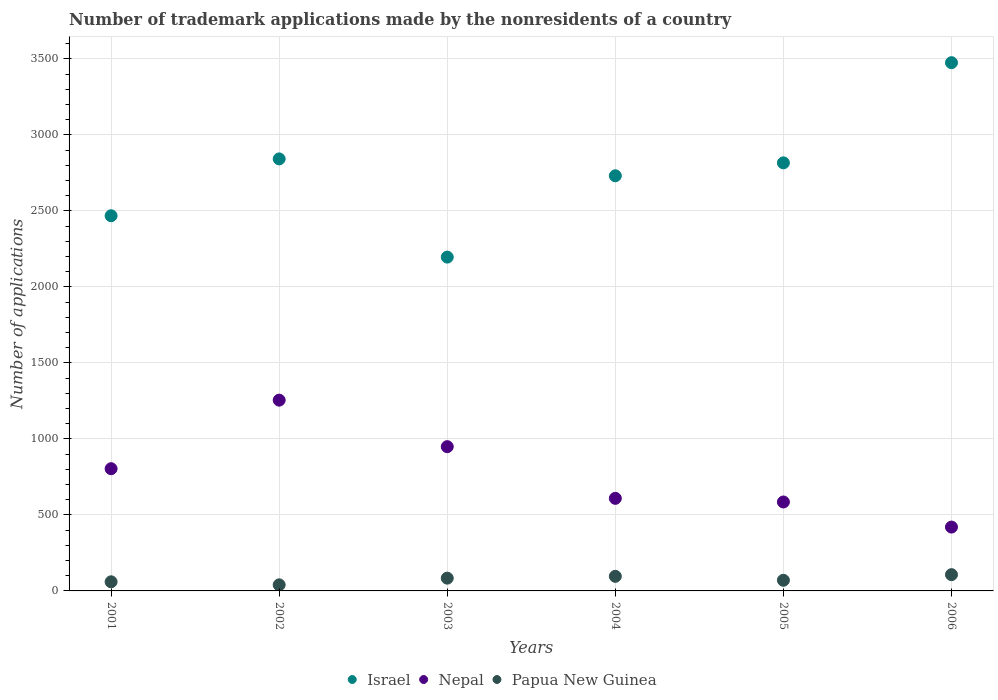How many different coloured dotlines are there?
Provide a succinct answer. 3. What is the number of trademark applications made by the nonresidents in Israel in 2006?
Your answer should be very brief. 3475. Across all years, what is the maximum number of trademark applications made by the nonresidents in Nepal?
Make the answer very short. 1255. Across all years, what is the minimum number of trademark applications made by the nonresidents in Nepal?
Your response must be concise. 420. In which year was the number of trademark applications made by the nonresidents in Israel maximum?
Provide a short and direct response. 2006. What is the total number of trademark applications made by the nonresidents in Papua New Guinea in the graph?
Keep it short and to the point. 457. What is the difference between the number of trademark applications made by the nonresidents in Nepal in 2001 and that in 2005?
Provide a short and direct response. 219. What is the difference between the number of trademark applications made by the nonresidents in Israel in 2001 and the number of trademark applications made by the nonresidents in Nepal in 2005?
Your answer should be very brief. 1883. What is the average number of trademark applications made by the nonresidents in Israel per year?
Keep it short and to the point. 2754.67. In the year 2002, what is the difference between the number of trademark applications made by the nonresidents in Papua New Guinea and number of trademark applications made by the nonresidents in Israel?
Your response must be concise. -2802. What is the ratio of the number of trademark applications made by the nonresidents in Israel in 2002 to that in 2006?
Provide a succinct answer. 0.82. Is the number of trademark applications made by the nonresidents in Papua New Guinea in 2005 less than that in 2006?
Give a very brief answer. Yes. Is the difference between the number of trademark applications made by the nonresidents in Papua New Guinea in 2003 and 2004 greater than the difference between the number of trademark applications made by the nonresidents in Israel in 2003 and 2004?
Your response must be concise. Yes. What is the difference between the highest and the second highest number of trademark applications made by the nonresidents in Nepal?
Ensure brevity in your answer.  306. In how many years, is the number of trademark applications made by the nonresidents in Papua New Guinea greater than the average number of trademark applications made by the nonresidents in Papua New Guinea taken over all years?
Your response must be concise. 3. Is the number of trademark applications made by the nonresidents in Papua New Guinea strictly less than the number of trademark applications made by the nonresidents in Israel over the years?
Give a very brief answer. Yes. How many years are there in the graph?
Your answer should be compact. 6. What is the difference between two consecutive major ticks on the Y-axis?
Your answer should be very brief. 500. Are the values on the major ticks of Y-axis written in scientific E-notation?
Your answer should be very brief. No. Does the graph contain any zero values?
Provide a short and direct response. No. Does the graph contain grids?
Offer a very short reply. Yes. Where does the legend appear in the graph?
Keep it short and to the point. Bottom center. How are the legend labels stacked?
Offer a terse response. Horizontal. What is the title of the graph?
Your answer should be very brief. Number of trademark applications made by the nonresidents of a country. Does "Eritrea" appear as one of the legend labels in the graph?
Provide a short and direct response. No. What is the label or title of the Y-axis?
Keep it short and to the point. Number of applications. What is the Number of applications in Israel in 2001?
Ensure brevity in your answer.  2468. What is the Number of applications of Nepal in 2001?
Your response must be concise. 804. What is the Number of applications of Israel in 2002?
Make the answer very short. 2842. What is the Number of applications in Nepal in 2002?
Offer a terse response. 1255. What is the Number of applications in Papua New Guinea in 2002?
Provide a short and direct response. 40. What is the Number of applications of Israel in 2003?
Your response must be concise. 2196. What is the Number of applications of Nepal in 2003?
Make the answer very short. 949. What is the Number of applications in Israel in 2004?
Your response must be concise. 2731. What is the Number of applications of Nepal in 2004?
Your answer should be compact. 609. What is the Number of applications in Papua New Guinea in 2004?
Make the answer very short. 96. What is the Number of applications of Israel in 2005?
Provide a short and direct response. 2816. What is the Number of applications in Nepal in 2005?
Offer a terse response. 585. What is the Number of applications of Israel in 2006?
Make the answer very short. 3475. What is the Number of applications in Nepal in 2006?
Provide a succinct answer. 420. What is the Number of applications in Papua New Guinea in 2006?
Offer a very short reply. 107. Across all years, what is the maximum Number of applications of Israel?
Ensure brevity in your answer.  3475. Across all years, what is the maximum Number of applications in Nepal?
Your response must be concise. 1255. Across all years, what is the maximum Number of applications of Papua New Guinea?
Offer a very short reply. 107. Across all years, what is the minimum Number of applications of Israel?
Your response must be concise. 2196. Across all years, what is the minimum Number of applications of Nepal?
Provide a succinct answer. 420. Across all years, what is the minimum Number of applications of Papua New Guinea?
Make the answer very short. 40. What is the total Number of applications in Israel in the graph?
Offer a very short reply. 1.65e+04. What is the total Number of applications in Nepal in the graph?
Keep it short and to the point. 4622. What is the total Number of applications in Papua New Guinea in the graph?
Provide a short and direct response. 457. What is the difference between the Number of applications in Israel in 2001 and that in 2002?
Offer a very short reply. -374. What is the difference between the Number of applications in Nepal in 2001 and that in 2002?
Make the answer very short. -451. What is the difference between the Number of applications in Israel in 2001 and that in 2003?
Your answer should be compact. 272. What is the difference between the Number of applications in Nepal in 2001 and that in 2003?
Offer a very short reply. -145. What is the difference between the Number of applications in Papua New Guinea in 2001 and that in 2003?
Make the answer very short. -24. What is the difference between the Number of applications of Israel in 2001 and that in 2004?
Keep it short and to the point. -263. What is the difference between the Number of applications of Nepal in 2001 and that in 2004?
Your answer should be compact. 195. What is the difference between the Number of applications in Papua New Guinea in 2001 and that in 2004?
Make the answer very short. -36. What is the difference between the Number of applications in Israel in 2001 and that in 2005?
Provide a short and direct response. -348. What is the difference between the Number of applications of Nepal in 2001 and that in 2005?
Offer a terse response. 219. What is the difference between the Number of applications of Israel in 2001 and that in 2006?
Offer a terse response. -1007. What is the difference between the Number of applications in Nepal in 2001 and that in 2006?
Give a very brief answer. 384. What is the difference between the Number of applications of Papua New Guinea in 2001 and that in 2006?
Make the answer very short. -47. What is the difference between the Number of applications in Israel in 2002 and that in 2003?
Ensure brevity in your answer.  646. What is the difference between the Number of applications of Nepal in 2002 and that in 2003?
Your answer should be very brief. 306. What is the difference between the Number of applications of Papua New Guinea in 2002 and that in 2003?
Provide a short and direct response. -44. What is the difference between the Number of applications of Israel in 2002 and that in 2004?
Your answer should be very brief. 111. What is the difference between the Number of applications of Nepal in 2002 and that in 2004?
Your answer should be compact. 646. What is the difference between the Number of applications in Papua New Guinea in 2002 and that in 2004?
Ensure brevity in your answer.  -56. What is the difference between the Number of applications in Israel in 2002 and that in 2005?
Your answer should be very brief. 26. What is the difference between the Number of applications in Nepal in 2002 and that in 2005?
Offer a very short reply. 670. What is the difference between the Number of applications of Israel in 2002 and that in 2006?
Your answer should be compact. -633. What is the difference between the Number of applications of Nepal in 2002 and that in 2006?
Keep it short and to the point. 835. What is the difference between the Number of applications of Papua New Guinea in 2002 and that in 2006?
Offer a very short reply. -67. What is the difference between the Number of applications of Israel in 2003 and that in 2004?
Give a very brief answer. -535. What is the difference between the Number of applications of Nepal in 2003 and that in 2004?
Keep it short and to the point. 340. What is the difference between the Number of applications in Israel in 2003 and that in 2005?
Your answer should be very brief. -620. What is the difference between the Number of applications in Nepal in 2003 and that in 2005?
Give a very brief answer. 364. What is the difference between the Number of applications of Israel in 2003 and that in 2006?
Provide a succinct answer. -1279. What is the difference between the Number of applications in Nepal in 2003 and that in 2006?
Offer a very short reply. 529. What is the difference between the Number of applications of Israel in 2004 and that in 2005?
Give a very brief answer. -85. What is the difference between the Number of applications of Papua New Guinea in 2004 and that in 2005?
Ensure brevity in your answer.  26. What is the difference between the Number of applications of Israel in 2004 and that in 2006?
Your response must be concise. -744. What is the difference between the Number of applications in Nepal in 2004 and that in 2006?
Offer a terse response. 189. What is the difference between the Number of applications in Israel in 2005 and that in 2006?
Provide a short and direct response. -659. What is the difference between the Number of applications of Nepal in 2005 and that in 2006?
Your response must be concise. 165. What is the difference between the Number of applications of Papua New Guinea in 2005 and that in 2006?
Make the answer very short. -37. What is the difference between the Number of applications in Israel in 2001 and the Number of applications in Nepal in 2002?
Your answer should be very brief. 1213. What is the difference between the Number of applications of Israel in 2001 and the Number of applications of Papua New Guinea in 2002?
Keep it short and to the point. 2428. What is the difference between the Number of applications of Nepal in 2001 and the Number of applications of Papua New Guinea in 2002?
Provide a succinct answer. 764. What is the difference between the Number of applications in Israel in 2001 and the Number of applications in Nepal in 2003?
Give a very brief answer. 1519. What is the difference between the Number of applications of Israel in 2001 and the Number of applications of Papua New Guinea in 2003?
Provide a short and direct response. 2384. What is the difference between the Number of applications in Nepal in 2001 and the Number of applications in Papua New Guinea in 2003?
Give a very brief answer. 720. What is the difference between the Number of applications in Israel in 2001 and the Number of applications in Nepal in 2004?
Ensure brevity in your answer.  1859. What is the difference between the Number of applications in Israel in 2001 and the Number of applications in Papua New Guinea in 2004?
Ensure brevity in your answer.  2372. What is the difference between the Number of applications of Nepal in 2001 and the Number of applications of Papua New Guinea in 2004?
Provide a succinct answer. 708. What is the difference between the Number of applications in Israel in 2001 and the Number of applications in Nepal in 2005?
Offer a terse response. 1883. What is the difference between the Number of applications of Israel in 2001 and the Number of applications of Papua New Guinea in 2005?
Make the answer very short. 2398. What is the difference between the Number of applications of Nepal in 2001 and the Number of applications of Papua New Guinea in 2005?
Provide a succinct answer. 734. What is the difference between the Number of applications in Israel in 2001 and the Number of applications in Nepal in 2006?
Your response must be concise. 2048. What is the difference between the Number of applications of Israel in 2001 and the Number of applications of Papua New Guinea in 2006?
Ensure brevity in your answer.  2361. What is the difference between the Number of applications in Nepal in 2001 and the Number of applications in Papua New Guinea in 2006?
Your answer should be very brief. 697. What is the difference between the Number of applications in Israel in 2002 and the Number of applications in Nepal in 2003?
Your response must be concise. 1893. What is the difference between the Number of applications of Israel in 2002 and the Number of applications of Papua New Guinea in 2003?
Your response must be concise. 2758. What is the difference between the Number of applications in Nepal in 2002 and the Number of applications in Papua New Guinea in 2003?
Your answer should be compact. 1171. What is the difference between the Number of applications of Israel in 2002 and the Number of applications of Nepal in 2004?
Keep it short and to the point. 2233. What is the difference between the Number of applications in Israel in 2002 and the Number of applications in Papua New Guinea in 2004?
Give a very brief answer. 2746. What is the difference between the Number of applications in Nepal in 2002 and the Number of applications in Papua New Guinea in 2004?
Your answer should be compact. 1159. What is the difference between the Number of applications of Israel in 2002 and the Number of applications of Nepal in 2005?
Provide a short and direct response. 2257. What is the difference between the Number of applications in Israel in 2002 and the Number of applications in Papua New Guinea in 2005?
Your answer should be very brief. 2772. What is the difference between the Number of applications in Nepal in 2002 and the Number of applications in Papua New Guinea in 2005?
Offer a very short reply. 1185. What is the difference between the Number of applications in Israel in 2002 and the Number of applications in Nepal in 2006?
Keep it short and to the point. 2422. What is the difference between the Number of applications of Israel in 2002 and the Number of applications of Papua New Guinea in 2006?
Offer a very short reply. 2735. What is the difference between the Number of applications of Nepal in 2002 and the Number of applications of Papua New Guinea in 2006?
Give a very brief answer. 1148. What is the difference between the Number of applications of Israel in 2003 and the Number of applications of Nepal in 2004?
Your answer should be compact. 1587. What is the difference between the Number of applications in Israel in 2003 and the Number of applications in Papua New Guinea in 2004?
Your response must be concise. 2100. What is the difference between the Number of applications in Nepal in 2003 and the Number of applications in Papua New Guinea in 2004?
Your answer should be compact. 853. What is the difference between the Number of applications in Israel in 2003 and the Number of applications in Nepal in 2005?
Give a very brief answer. 1611. What is the difference between the Number of applications of Israel in 2003 and the Number of applications of Papua New Guinea in 2005?
Provide a short and direct response. 2126. What is the difference between the Number of applications in Nepal in 2003 and the Number of applications in Papua New Guinea in 2005?
Give a very brief answer. 879. What is the difference between the Number of applications in Israel in 2003 and the Number of applications in Nepal in 2006?
Offer a very short reply. 1776. What is the difference between the Number of applications of Israel in 2003 and the Number of applications of Papua New Guinea in 2006?
Provide a short and direct response. 2089. What is the difference between the Number of applications of Nepal in 2003 and the Number of applications of Papua New Guinea in 2006?
Offer a terse response. 842. What is the difference between the Number of applications of Israel in 2004 and the Number of applications of Nepal in 2005?
Give a very brief answer. 2146. What is the difference between the Number of applications of Israel in 2004 and the Number of applications of Papua New Guinea in 2005?
Keep it short and to the point. 2661. What is the difference between the Number of applications in Nepal in 2004 and the Number of applications in Papua New Guinea in 2005?
Your answer should be very brief. 539. What is the difference between the Number of applications of Israel in 2004 and the Number of applications of Nepal in 2006?
Keep it short and to the point. 2311. What is the difference between the Number of applications of Israel in 2004 and the Number of applications of Papua New Guinea in 2006?
Provide a succinct answer. 2624. What is the difference between the Number of applications of Nepal in 2004 and the Number of applications of Papua New Guinea in 2006?
Give a very brief answer. 502. What is the difference between the Number of applications of Israel in 2005 and the Number of applications of Nepal in 2006?
Make the answer very short. 2396. What is the difference between the Number of applications in Israel in 2005 and the Number of applications in Papua New Guinea in 2006?
Your answer should be compact. 2709. What is the difference between the Number of applications in Nepal in 2005 and the Number of applications in Papua New Guinea in 2006?
Give a very brief answer. 478. What is the average Number of applications in Israel per year?
Provide a succinct answer. 2754.67. What is the average Number of applications of Nepal per year?
Offer a terse response. 770.33. What is the average Number of applications in Papua New Guinea per year?
Offer a very short reply. 76.17. In the year 2001, what is the difference between the Number of applications in Israel and Number of applications in Nepal?
Offer a very short reply. 1664. In the year 2001, what is the difference between the Number of applications of Israel and Number of applications of Papua New Guinea?
Ensure brevity in your answer.  2408. In the year 2001, what is the difference between the Number of applications of Nepal and Number of applications of Papua New Guinea?
Provide a short and direct response. 744. In the year 2002, what is the difference between the Number of applications in Israel and Number of applications in Nepal?
Your response must be concise. 1587. In the year 2002, what is the difference between the Number of applications in Israel and Number of applications in Papua New Guinea?
Ensure brevity in your answer.  2802. In the year 2002, what is the difference between the Number of applications in Nepal and Number of applications in Papua New Guinea?
Provide a succinct answer. 1215. In the year 2003, what is the difference between the Number of applications in Israel and Number of applications in Nepal?
Your answer should be compact. 1247. In the year 2003, what is the difference between the Number of applications in Israel and Number of applications in Papua New Guinea?
Offer a terse response. 2112. In the year 2003, what is the difference between the Number of applications of Nepal and Number of applications of Papua New Guinea?
Offer a terse response. 865. In the year 2004, what is the difference between the Number of applications in Israel and Number of applications in Nepal?
Your response must be concise. 2122. In the year 2004, what is the difference between the Number of applications of Israel and Number of applications of Papua New Guinea?
Your answer should be very brief. 2635. In the year 2004, what is the difference between the Number of applications of Nepal and Number of applications of Papua New Guinea?
Your answer should be very brief. 513. In the year 2005, what is the difference between the Number of applications in Israel and Number of applications in Nepal?
Keep it short and to the point. 2231. In the year 2005, what is the difference between the Number of applications in Israel and Number of applications in Papua New Guinea?
Provide a short and direct response. 2746. In the year 2005, what is the difference between the Number of applications in Nepal and Number of applications in Papua New Guinea?
Provide a succinct answer. 515. In the year 2006, what is the difference between the Number of applications in Israel and Number of applications in Nepal?
Ensure brevity in your answer.  3055. In the year 2006, what is the difference between the Number of applications of Israel and Number of applications of Papua New Guinea?
Offer a very short reply. 3368. In the year 2006, what is the difference between the Number of applications of Nepal and Number of applications of Papua New Guinea?
Your answer should be very brief. 313. What is the ratio of the Number of applications of Israel in 2001 to that in 2002?
Give a very brief answer. 0.87. What is the ratio of the Number of applications of Nepal in 2001 to that in 2002?
Your answer should be compact. 0.64. What is the ratio of the Number of applications in Papua New Guinea in 2001 to that in 2002?
Offer a terse response. 1.5. What is the ratio of the Number of applications in Israel in 2001 to that in 2003?
Your answer should be very brief. 1.12. What is the ratio of the Number of applications of Nepal in 2001 to that in 2003?
Your answer should be compact. 0.85. What is the ratio of the Number of applications in Papua New Guinea in 2001 to that in 2003?
Offer a terse response. 0.71. What is the ratio of the Number of applications in Israel in 2001 to that in 2004?
Your response must be concise. 0.9. What is the ratio of the Number of applications in Nepal in 2001 to that in 2004?
Ensure brevity in your answer.  1.32. What is the ratio of the Number of applications of Papua New Guinea in 2001 to that in 2004?
Provide a succinct answer. 0.62. What is the ratio of the Number of applications in Israel in 2001 to that in 2005?
Provide a short and direct response. 0.88. What is the ratio of the Number of applications in Nepal in 2001 to that in 2005?
Give a very brief answer. 1.37. What is the ratio of the Number of applications in Papua New Guinea in 2001 to that in 2005?
Make the answer very short. 0.86. What is the ratio of the Number of applications of Israel in 2001 to that in 2006?
Your answer should be very brief. 0.71. What is the ratio of the Number of applications in Nepal in 2001 to that in 2006?
Ensure brevity in your answer.  1.91. What is the ratio of the Number of applications of Papua New Guinea in 2001 to that in 2006?
Provide a succinct answer. 0.56. What is the ratio of the Number of applications of Israel in 2002 to that in 2003?
Keep it short and to the point. 1.29. What is the ratio of the Number of applications in Nepal in 2002 to that in 2003?
Ensure brevity in your answer.  1.32. What is the ratio of the Number of applications of Papua New Guinea in 2002 to that in 2003?
Provide a short and direct response. 0.48. What is the ratio of the Number of applications in Israel in 2002 to that in 2004?
Keep it short and to the point. 1.04. What is the ratio of the Number of applications in Nepal in 2002 to that in 2004?
Give a very brief answer. 2.06. What is the ratio of the Number of applications in Papua New Guinea in 2002 to that in 2004?
Ensure brevity in your answer.  0.42. What is the ratio of the Number of applications in Israel in 2002 to that in 2005?
Offer a very short reply. 1.01. What is the ratio of the Number of applications of Nepal in 2002 to that in 2005?
Ensure brevity in your answer.  2.15. What is the ratio of the Number of applications of Papua New Guinea in 2002 to that in 2005?
Your answer should be compact. 0.57. What is the ratio of the Number of applications in Israel in 2002 to that in 2006?
Your answer should be compact. 0.82. What is the ratio of the Number of applications of Nepal in 2002 to that in 2006?
Offer a terse response. 2.99. What is the ratio of the Number of applications in Papua New Guinea in 2002 to that in 2006?
Offer a terse response. 0.37. What is the ratio of the Number of applications of Israel in 2003 to that in 2004?
Provide a succinct answer. 0.8. What is the ratio of the Number of applications in Nepal in 2003 to that in 2004?
Keep it short and to the point. 1.56. What is the ratio of the Number of applications of Papua New Guinea in 2003 to that in 2004?
Provide a succinct answer. 0.88. What is the ratio of the Number of applications in Israel in 2003 to that in 2005?
Give a very brief answer. 0.78. What is the ratio of the Number of applications of Nepal in 2003 to that in 2005?
Keep it short and to the point. 1.62. What is the ratio of the Number of applications in Papua New Guinea in 2003 to that in 2005?
Your answer should be very brief. 1.2. What is the ratio of the Number of applications in Israel in 2003 to that in 2006?
Make the answer very short. 0.63. What is the ratio of the Number of applications of Nepal in 2003 to that in 2006?
Provide a short and direct response. 2.26. What is the ratio of the Number of applications in Papua New Guinea in 2003 to that in 2006?
Your answer should be very brief. 0.79. What is the ratio of the Number of applications in Israel in 2004 to that in 2005?
Offer a very short reply. 0.97. What is the ratio of the Number of applications in Nepal in 2004 to that in 2005?
Give a very brief answer. 1.04. What is the ratio of the Number of applications in Papua New Guinea in 2004 to that in 2005?
Provide a short and direct response. 1.37. What is the ratio of the Number of applications of Israel in 2004 to that in 2006?
Keep it short and to the point. 0.79. What is the ratio of the Number of applications of Nepal in 2004 to that in 2006?
Ensure brevity in your answer.  1.45. What is the ratio of the Number of applications in Papua New Guinea in 2004 to that in 2006?
Give a very brief answer. 0.9. What is the ratio of the Number of applications in Israel in 2005 to that in 2006?
Provide a succinct answer. 0.81. What is the ratio of the Number of applications of Nepal in 2005 to that in 2006?
Make the answer very short. 1.39. What is the ratio of the Number of applications of Papua New Guinea in 2005 to that in 2006?
Make the answer very short. 0.65. What is the difference between the highest and the second highest Number of applications in Israel?
Your answer should be compact. 633. What is the difference between the highest and the second highest Number of applications of Nepal?
Your response must be concise. 306. What is the difference between the highest and the second highest Number of applications in Papua New Guinea?
Your answer should be very brief. 11. What is the difference between the highest and the lowest Number of applications of Israel?
Keep it short and to the point. 1279. What is the difference between the highest and the lowest Number of applications of Nepal?
Your response must be concise. 835. What is the difference between the highest and the lowest Number of applications of Papua New Guinea?
Your answer should be very brief. 67. 